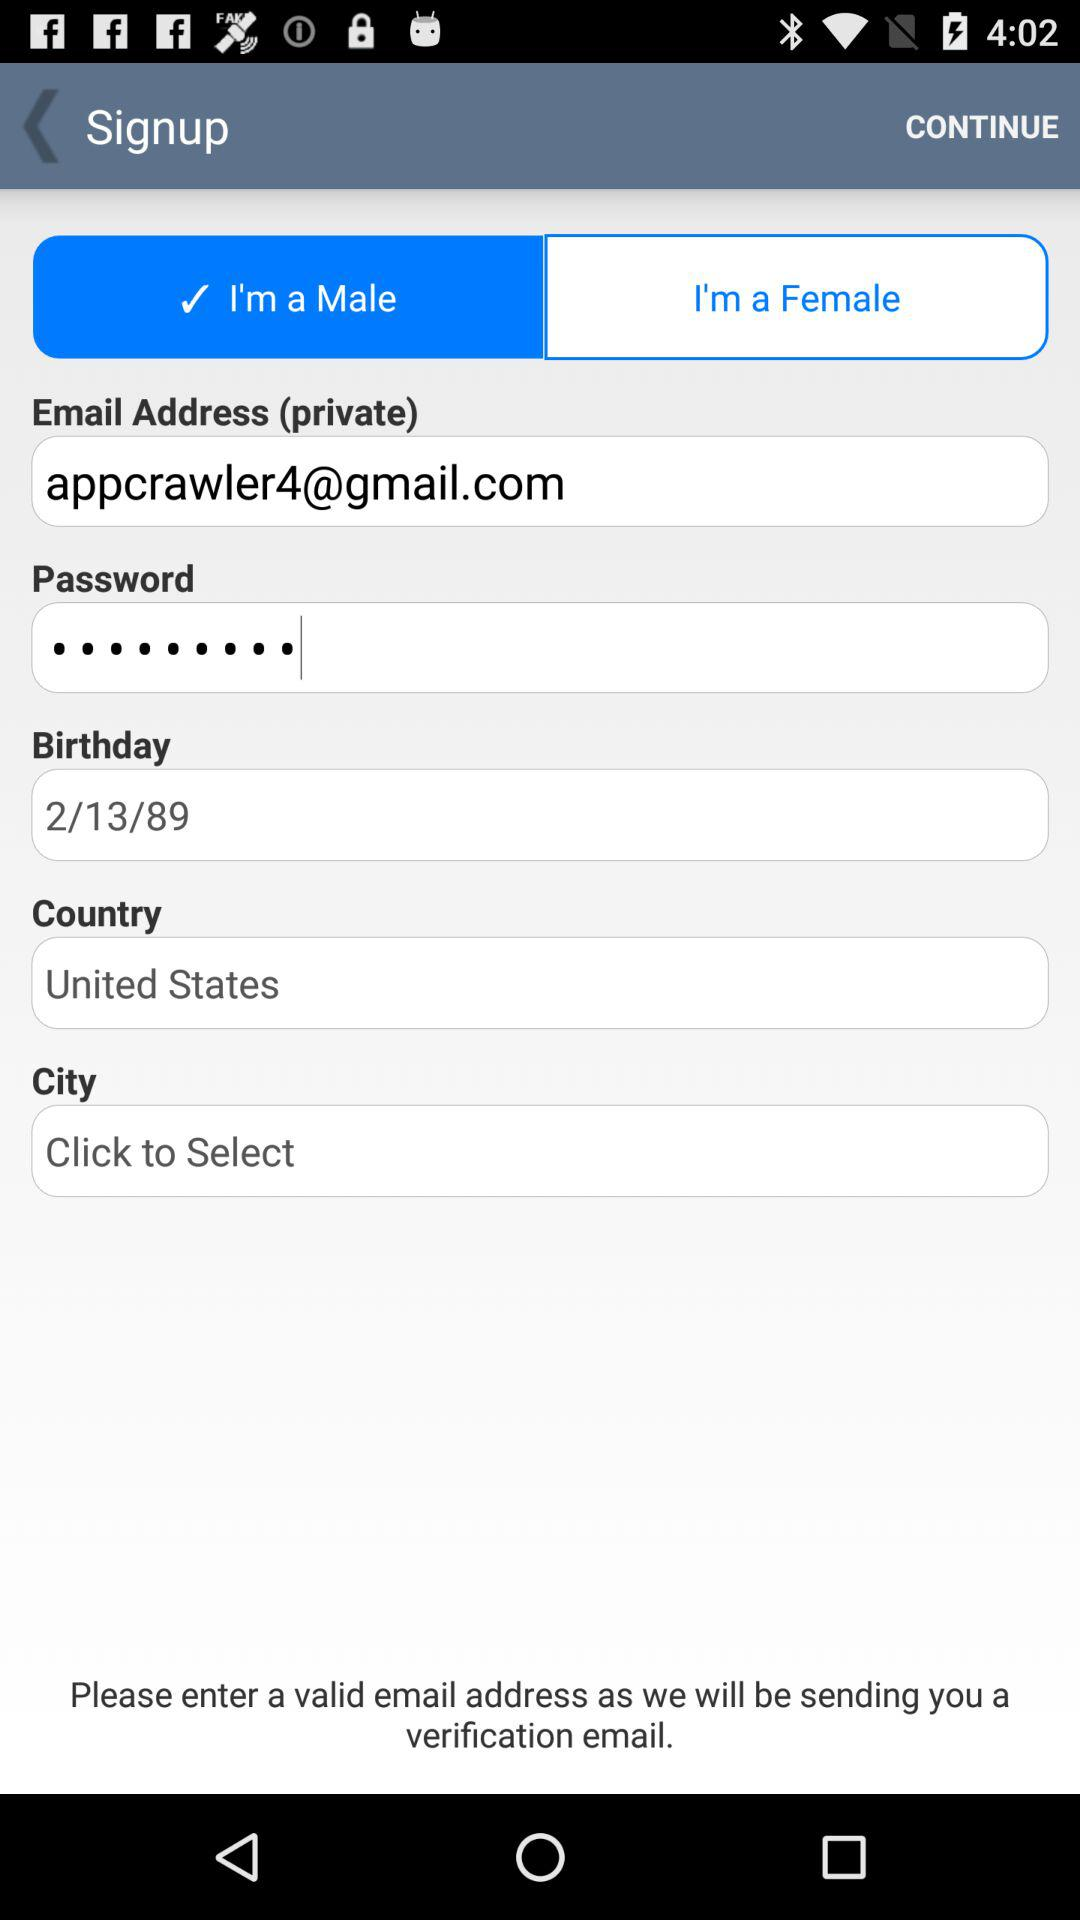What's the country name? The country name is the United States. 